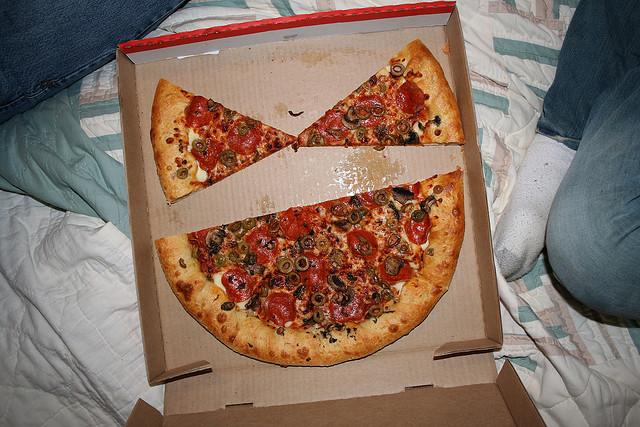Can you see a face in the pizza?
Answer briefly. Yes. Did someone not finish his pizza?
Quick response, please. Yes. How much pizza is missing?
Quick response, please. 2 slices. What has the pizza been formed to look like?
Write a very short answer. Face. 